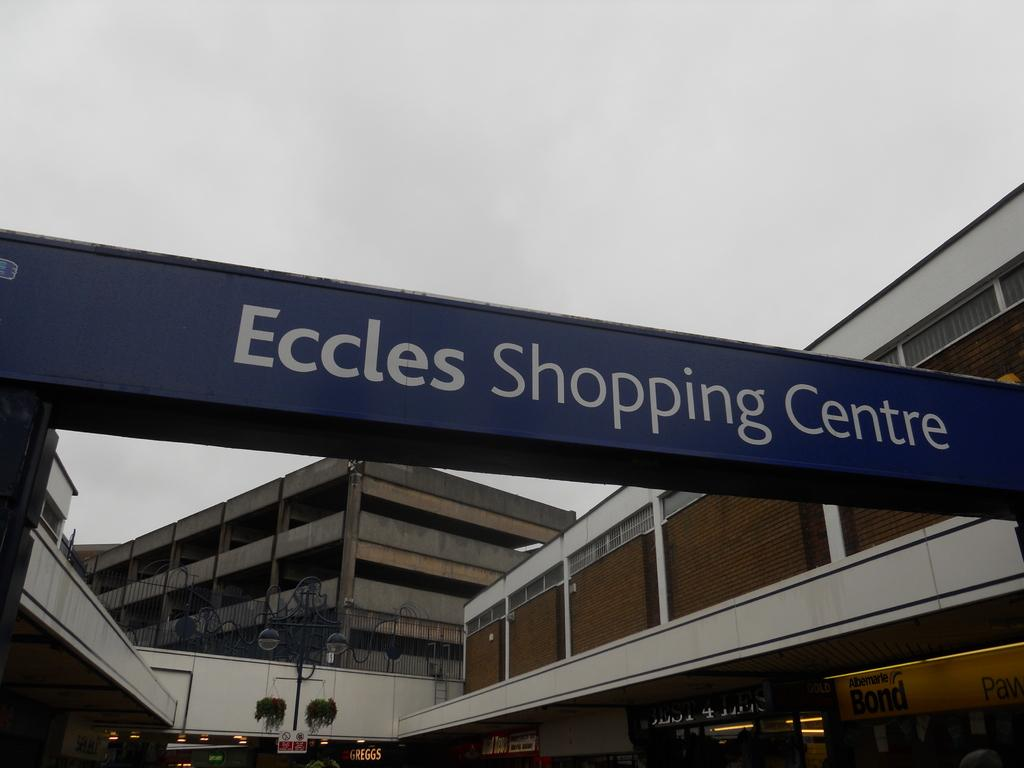What type of structures can be seen in the image? There are buildings in the image. What is the board with writing used for? The board with writing is likely used for displaying information or advertising. How many boards are visible in the image? There are additional boards in the image, but the exact number is not specified. What else can be seen in the image besides the buildings and boards? There are poles in the image. What type of toy is being played with on the board in the image? There is no toy visible on the board in the image; it only contains writing. 